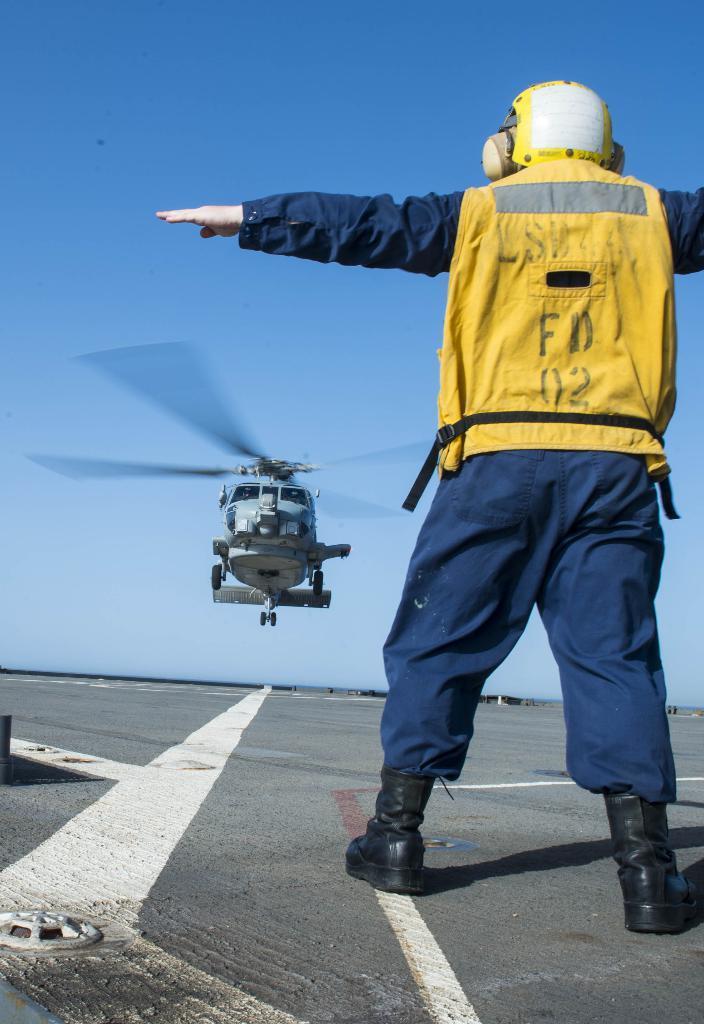In one or two sentences, can you explain what this image depicts? In the foreground I can see a person is standing on the road. In the background I can see an aircraft and the blue sky. This image is taken during a day. 